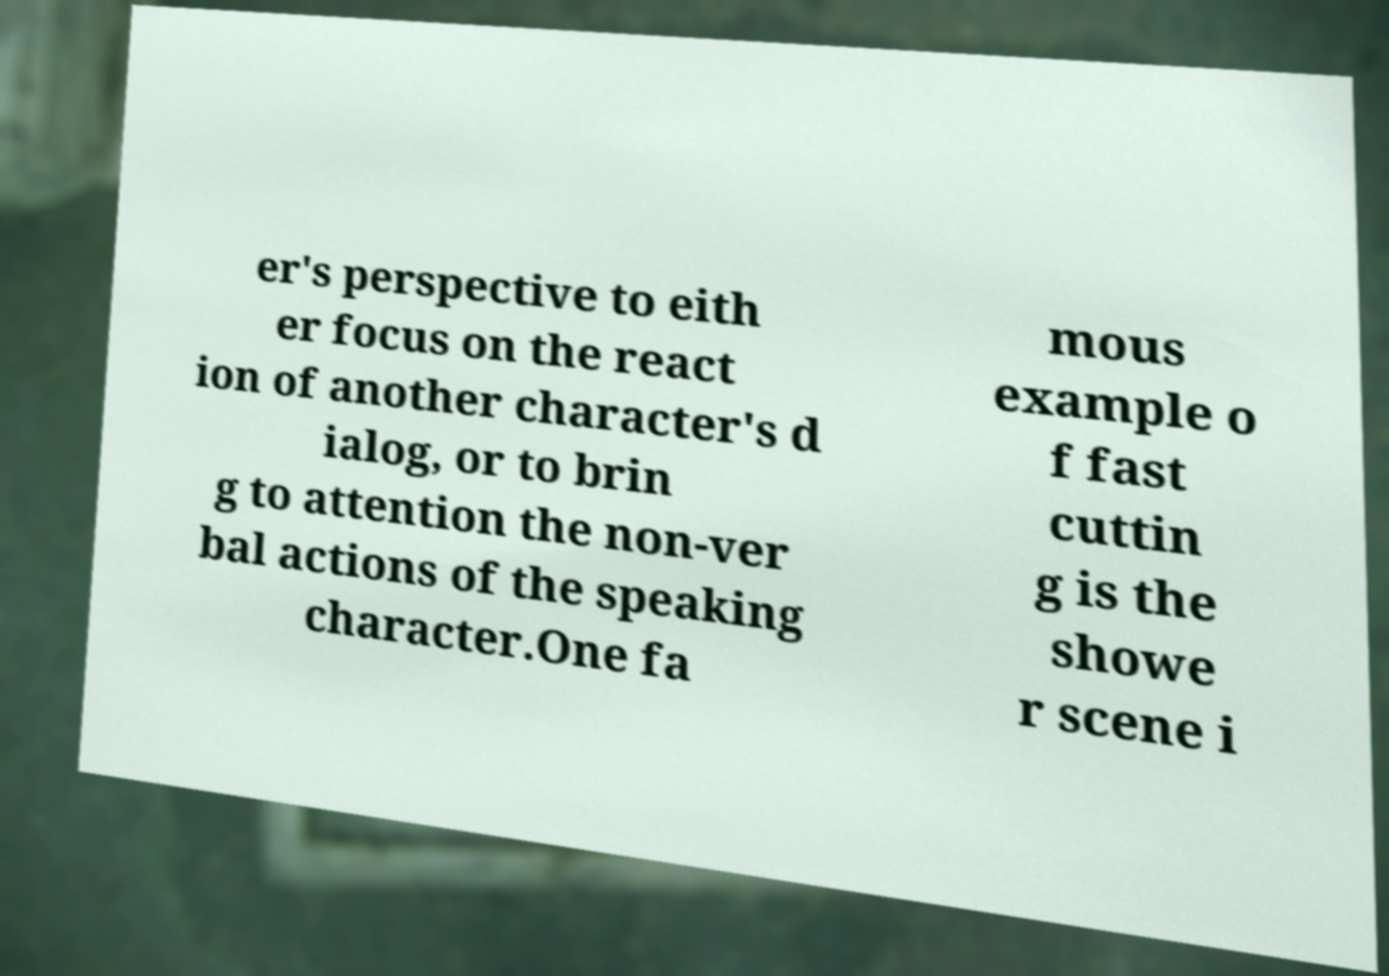Please read and relay the text visible in this image. What does it say? er's perspective to eith er focus on the react ion of another character's d ialog, or to brin g to attention the non-ver bal actions of the speaking character.One fa mous example o f fast cuttin g is the showe r scene i 